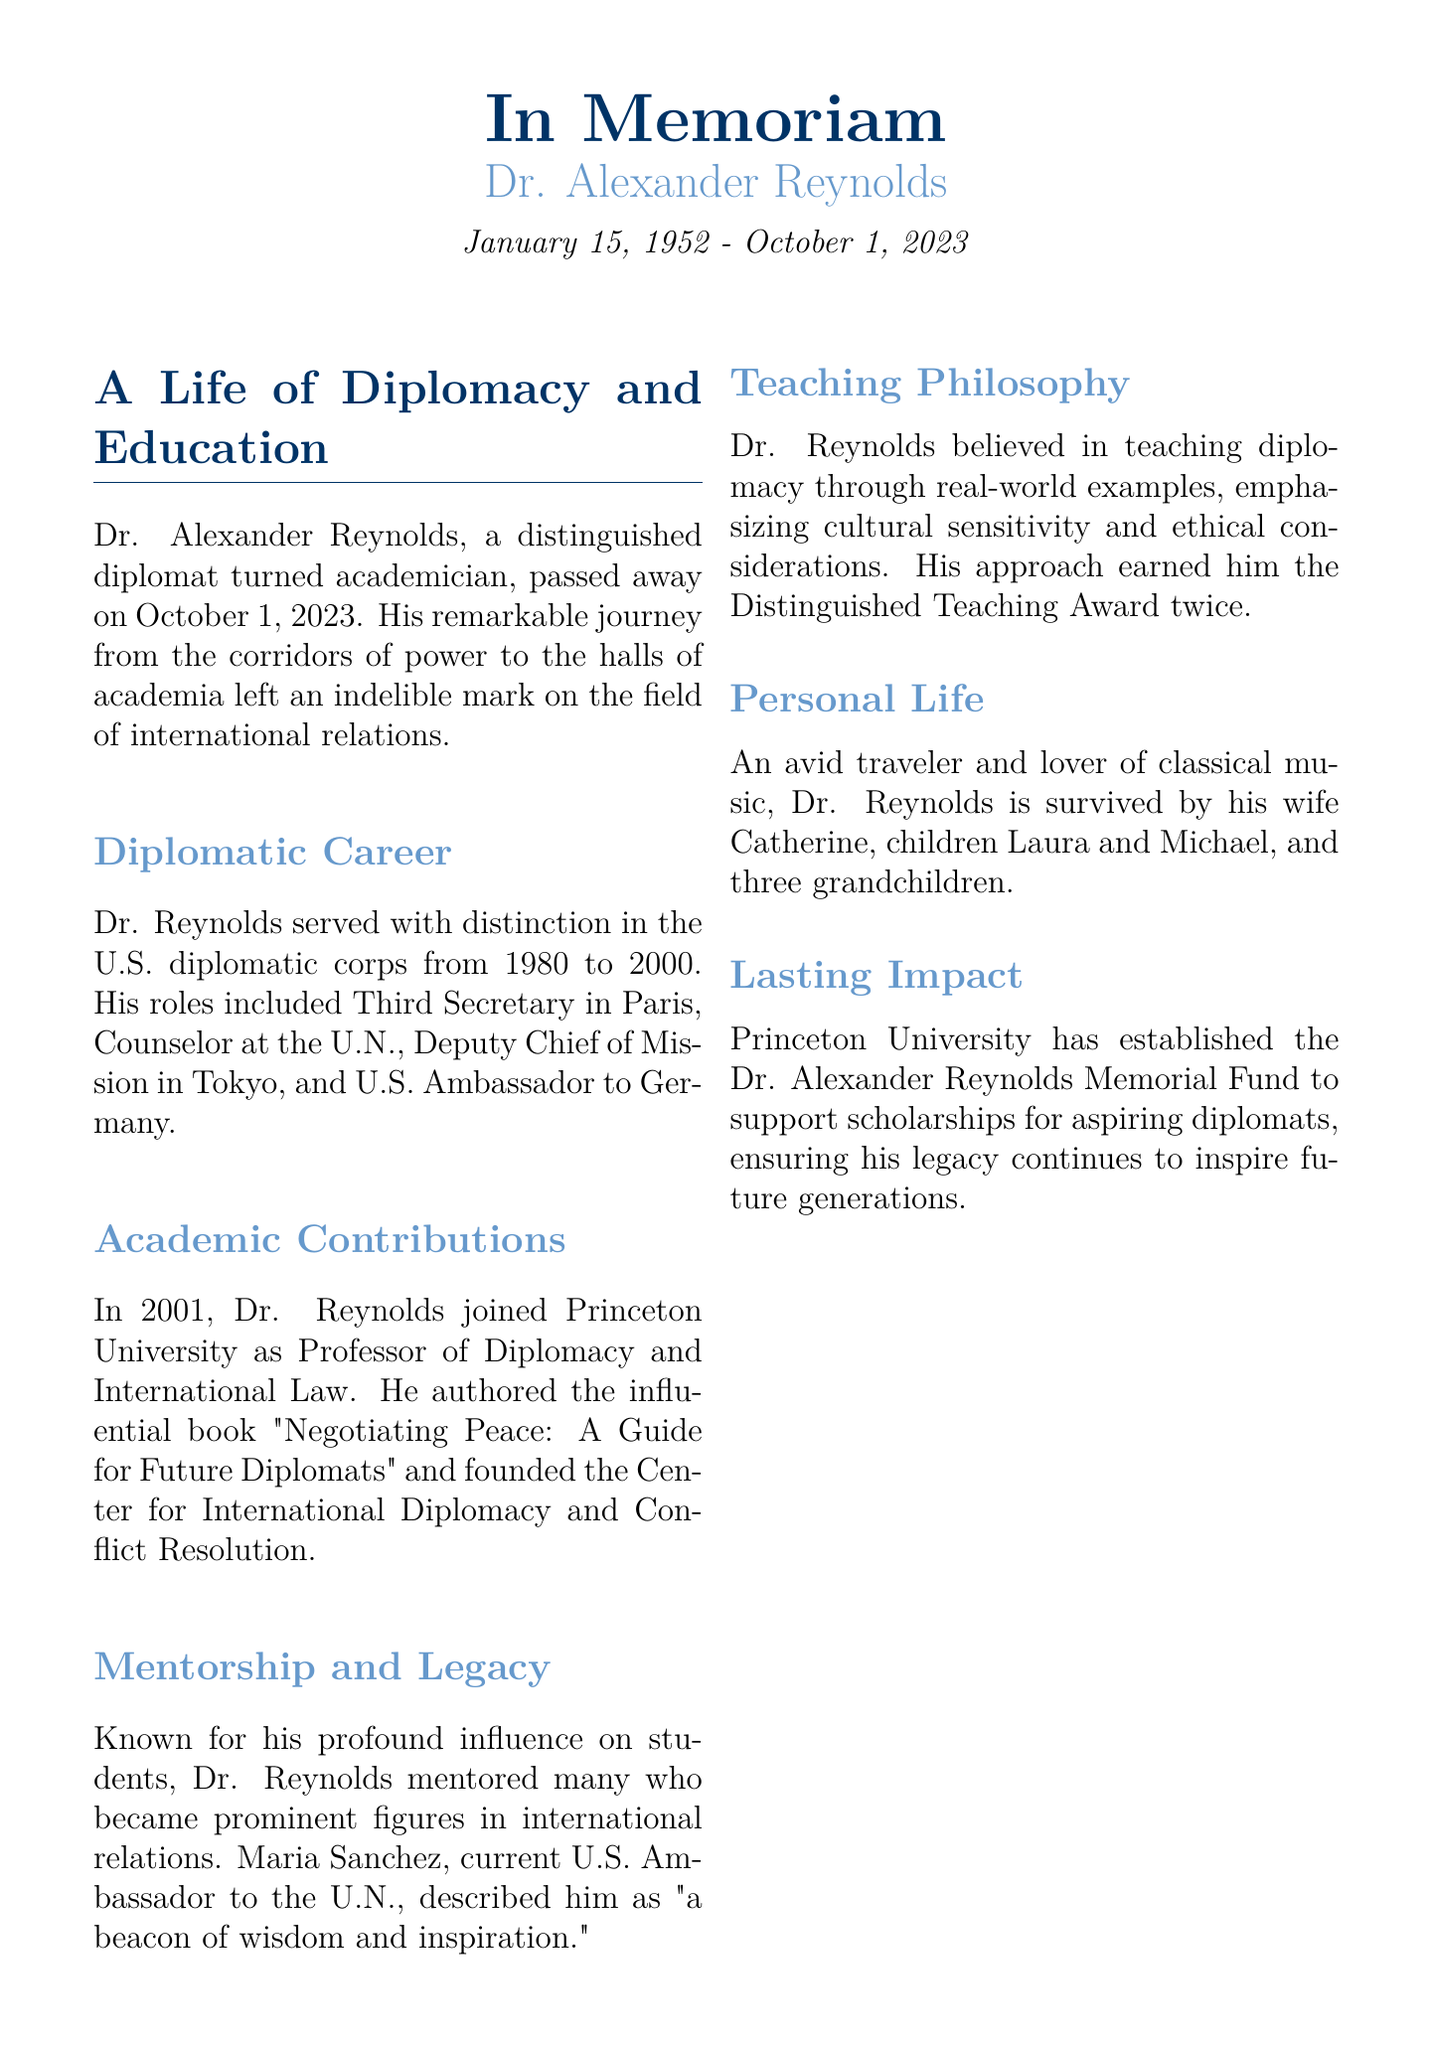What was Dr. Alexander Reynolds' profession before academia? Dr. Reynolds was a diplomat before joining academia, as indicated by his roles in the U.S. diplomatic corps.
Answer: diplomat What years did Dr. Reynolds serve in the U.S. diplomatic corps? The document specifies that Dr. Reynolds served from 1980 to 2000.
Answer: 1980 to 2000 What is the name of the book authored by Dr. Reynolds? The book authored by Dr. Reynolds is titled "Negotiating Peace: A Guide for Future Diplomats."
Answer: "Negotiating Peace: A Guide for Future Diplomats" Which award did Dr. Reynolds win twice? The document mentions that he won the Distinguished Teaching Award twice.
Answer: Distinguished Teaching Award Who is cited as describing Dr. Reynolds as "a beacon of wisdom and inspiration"? The document attributes this description to Maria Sanchez, who is the current U.S. Ambassador to the U.N.
Answer: Maria Sanchez What did Dr. Reynolds establish at Princeton University? He founded the Center for International Diplomacy and Conflict Resolution at Princeton University.
Answer: Center for International Diplomacy and Conflict Resolution What initiative was created in memory of Dr. Reynolds at Princeton University? The Dr. Alexander Reynolds Memorial Fund was established to support scholarships for aspiring diplomats.
Answer: Dr. Alexander Reynolds Memorial Fund What are the names of Dr. Reynolds' children? The document names his children as Laura and Michael.
Answer: Laura and Michael 